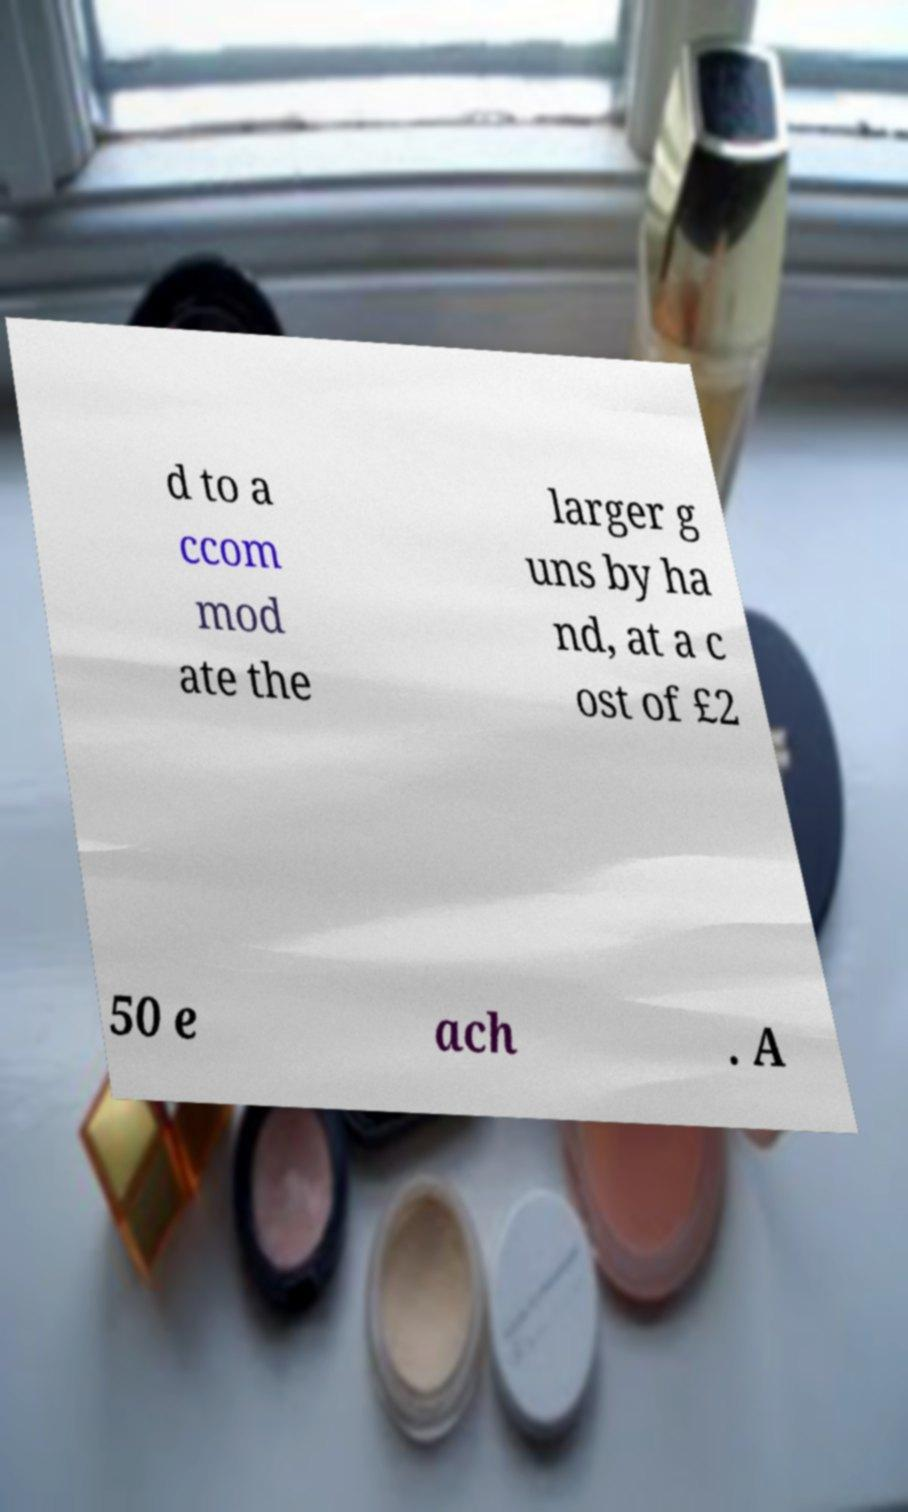What messages or text are displayed in this image? I need them in a readable, typed format. d to a ccom mod ate the larger g uns by ha nd, at a c ost of £2 50 e ach . A 